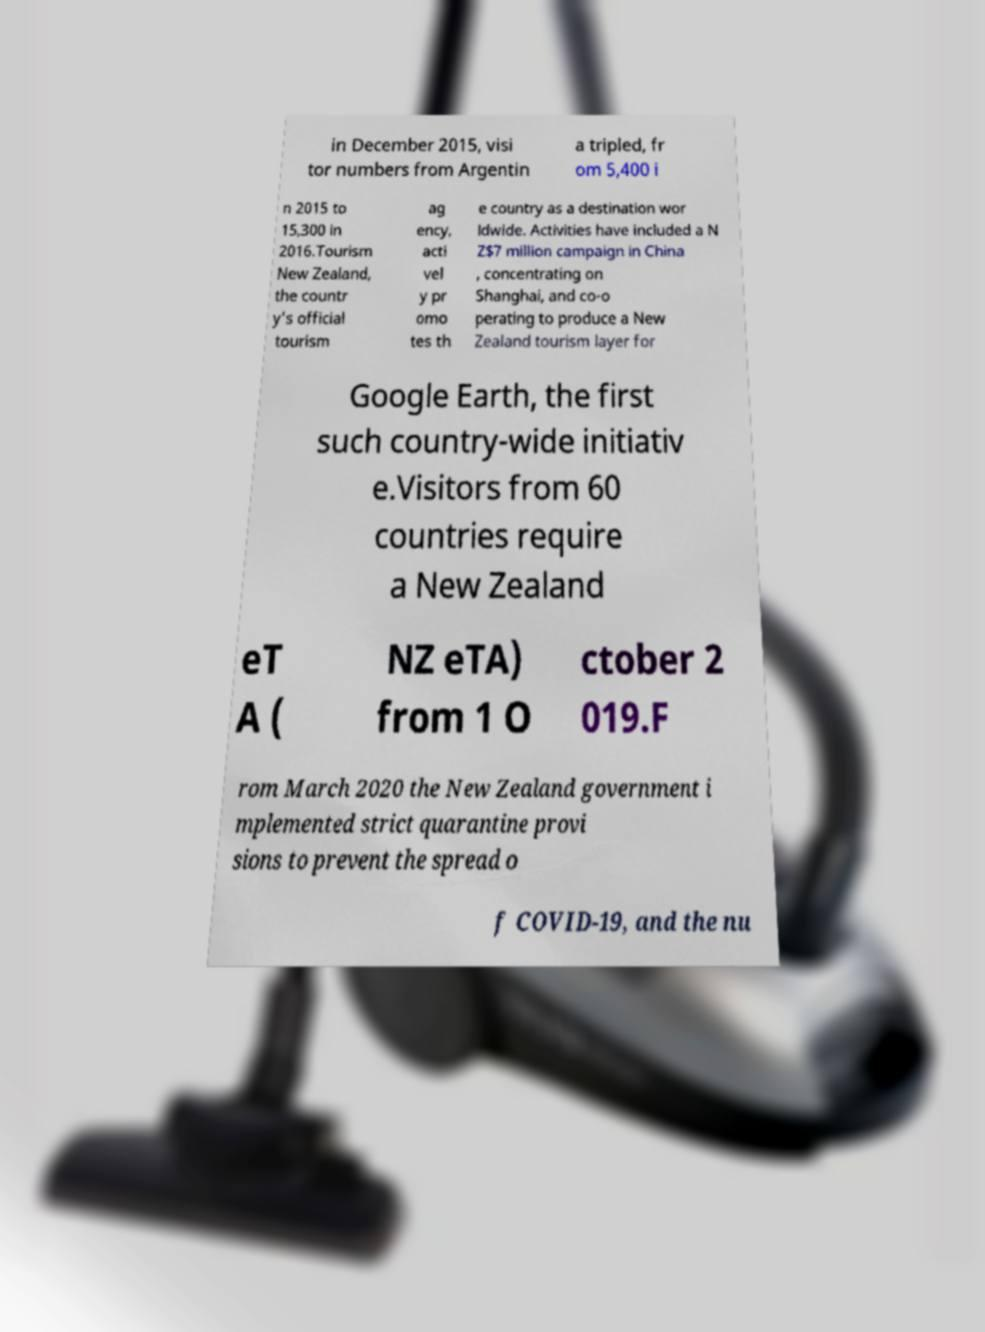I need the written content from this picture converted into text. Can you do that? in December 2015, visi tor numbers from Argentin a tripled, fr om 5,400 i n 2015 to 15,300 in 2016.Tourism New Zealand, the countr y's official tourism ag ency, acti vel y pr omo tes th e country as a destination wor ldwide. Activities have included a N Z$7 million campaign in China , concentrating on Shanghai, and co-o perating to produce a New Zealand tourism layer for Google Earth, the first such country-wide initiativ e.Visitors from 60 countries require a New Zealand eT A ( NZ eTA) from 1 O ctober 2 019.F rom March 2020 the New Zealand government i mplemented strict quarantine provi sions to prevent the spread o f COVID-19, and the nu 